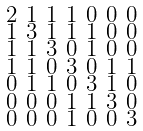Convert formula to latex. <formula><loc_0><loc_0><loc_500><loc_500>\begin{smallmatrix} 2 & 1 & 1 & 1 & 0 & 0 & 0 \\ 1 & 3 & 1 & 1 & 1 & 0 & 0 \\ 1 & 1 & 3 & 0 & 1 & 0 & 0 \\ 1 & 1 & 0 & 3 & 0 & 1 & 1 \\ 0 & 1 & 1 & 0 & 3 & 1 & 0 \\ 0 & 0 & 0 & 1 & 1 & 3 & 0 \\ 0 & 0 & 0 & 1 & 0 & 0 & 3 \end{smallmatrix}</formula> 